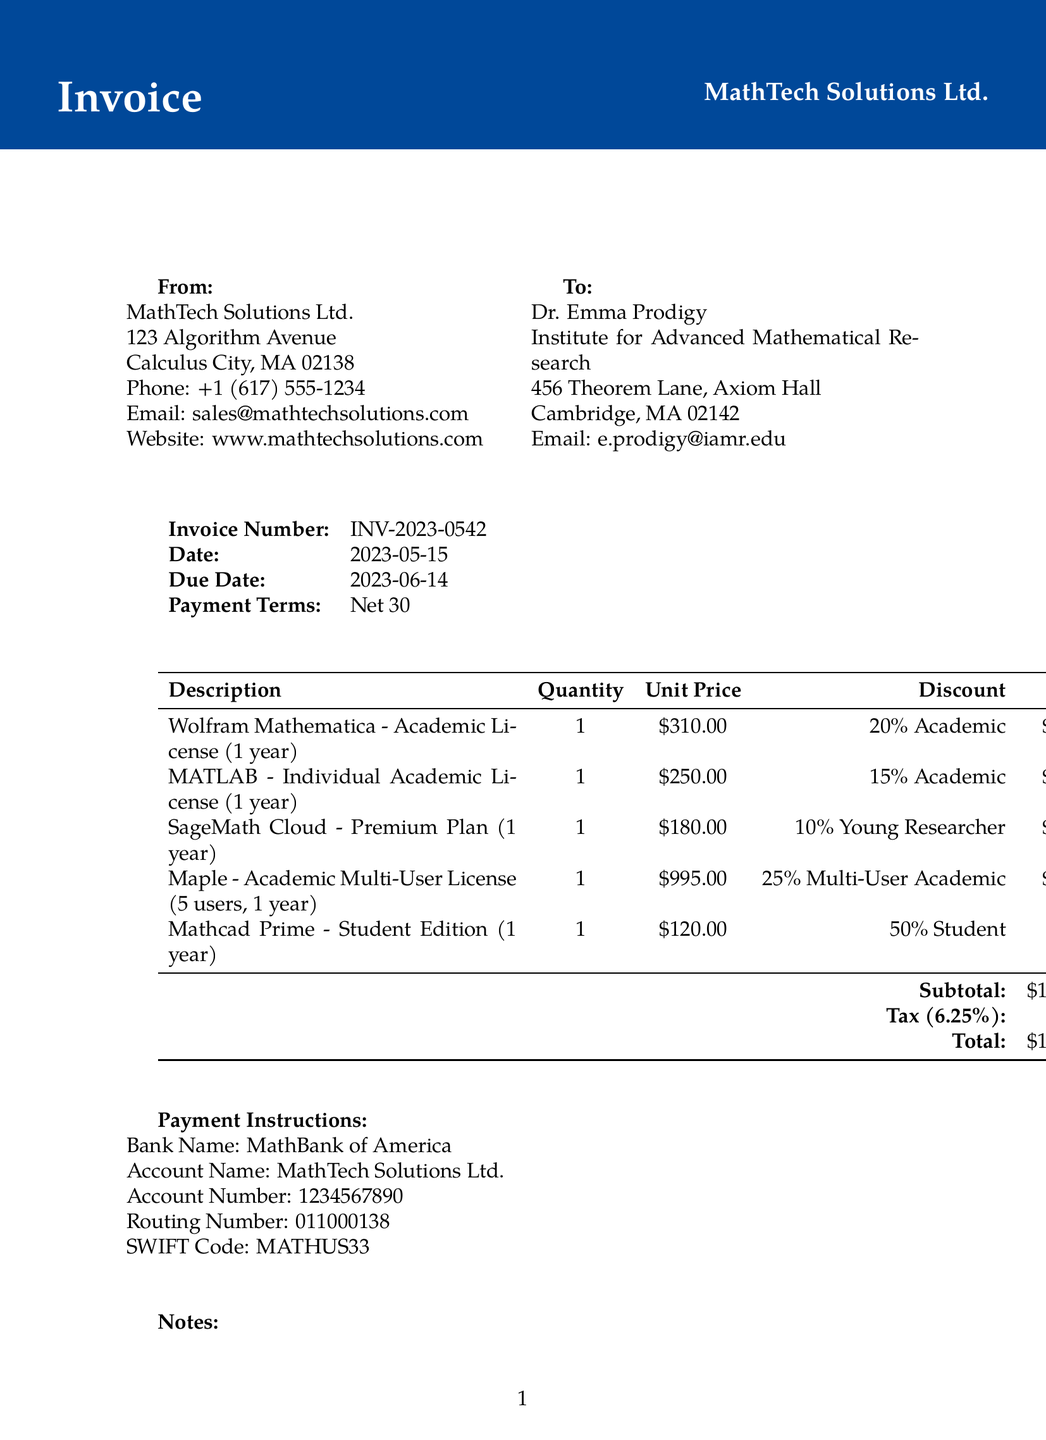What is the invoice number? The invoice number is clearly stated in the document under invoice details, which is INV-2023-0542.
Answer: INV-2023-0542 Who is the client? The client information section specifies the recipient of the invoice, which is Dr. Emma Prodigy.
Answer: Dr. Emma Prodigy What is the total amount due? The total amount due is calculated as the subtotal plus tax, found at the bottom of the invoice, which states $1,518.05.
Answer: $1,518.05 What discount is applied to Maple? The discount for Maple is listed in the items section, which states a 25% Multi-User Academic Discount.
Answer: 25% Multi-User Academic Discount What is the due date for the invoice? The document provides the due date under the invoice details, which is 2023-06-14.
Answer: 2023-06-14 How many software licenses were purchased in total? By counting the items listed in the invoice, the total number of licenses purchased is indicated as five, referring to the multi-user license.
Answer: Five What is the bank name for payment? The payment instructions section includes the bank name, which is MathBank of America.
Answer: MathBank of America What is the tax rate applied in this invoice? The tax rate can be found in the invoice details, which explicitly states a rate of 6.25%.
Answer: 6.25% What type of invoice is this document classified as? The document is classified as an invoice, as stated at the top of the rendered document.
Answer: Invoice 